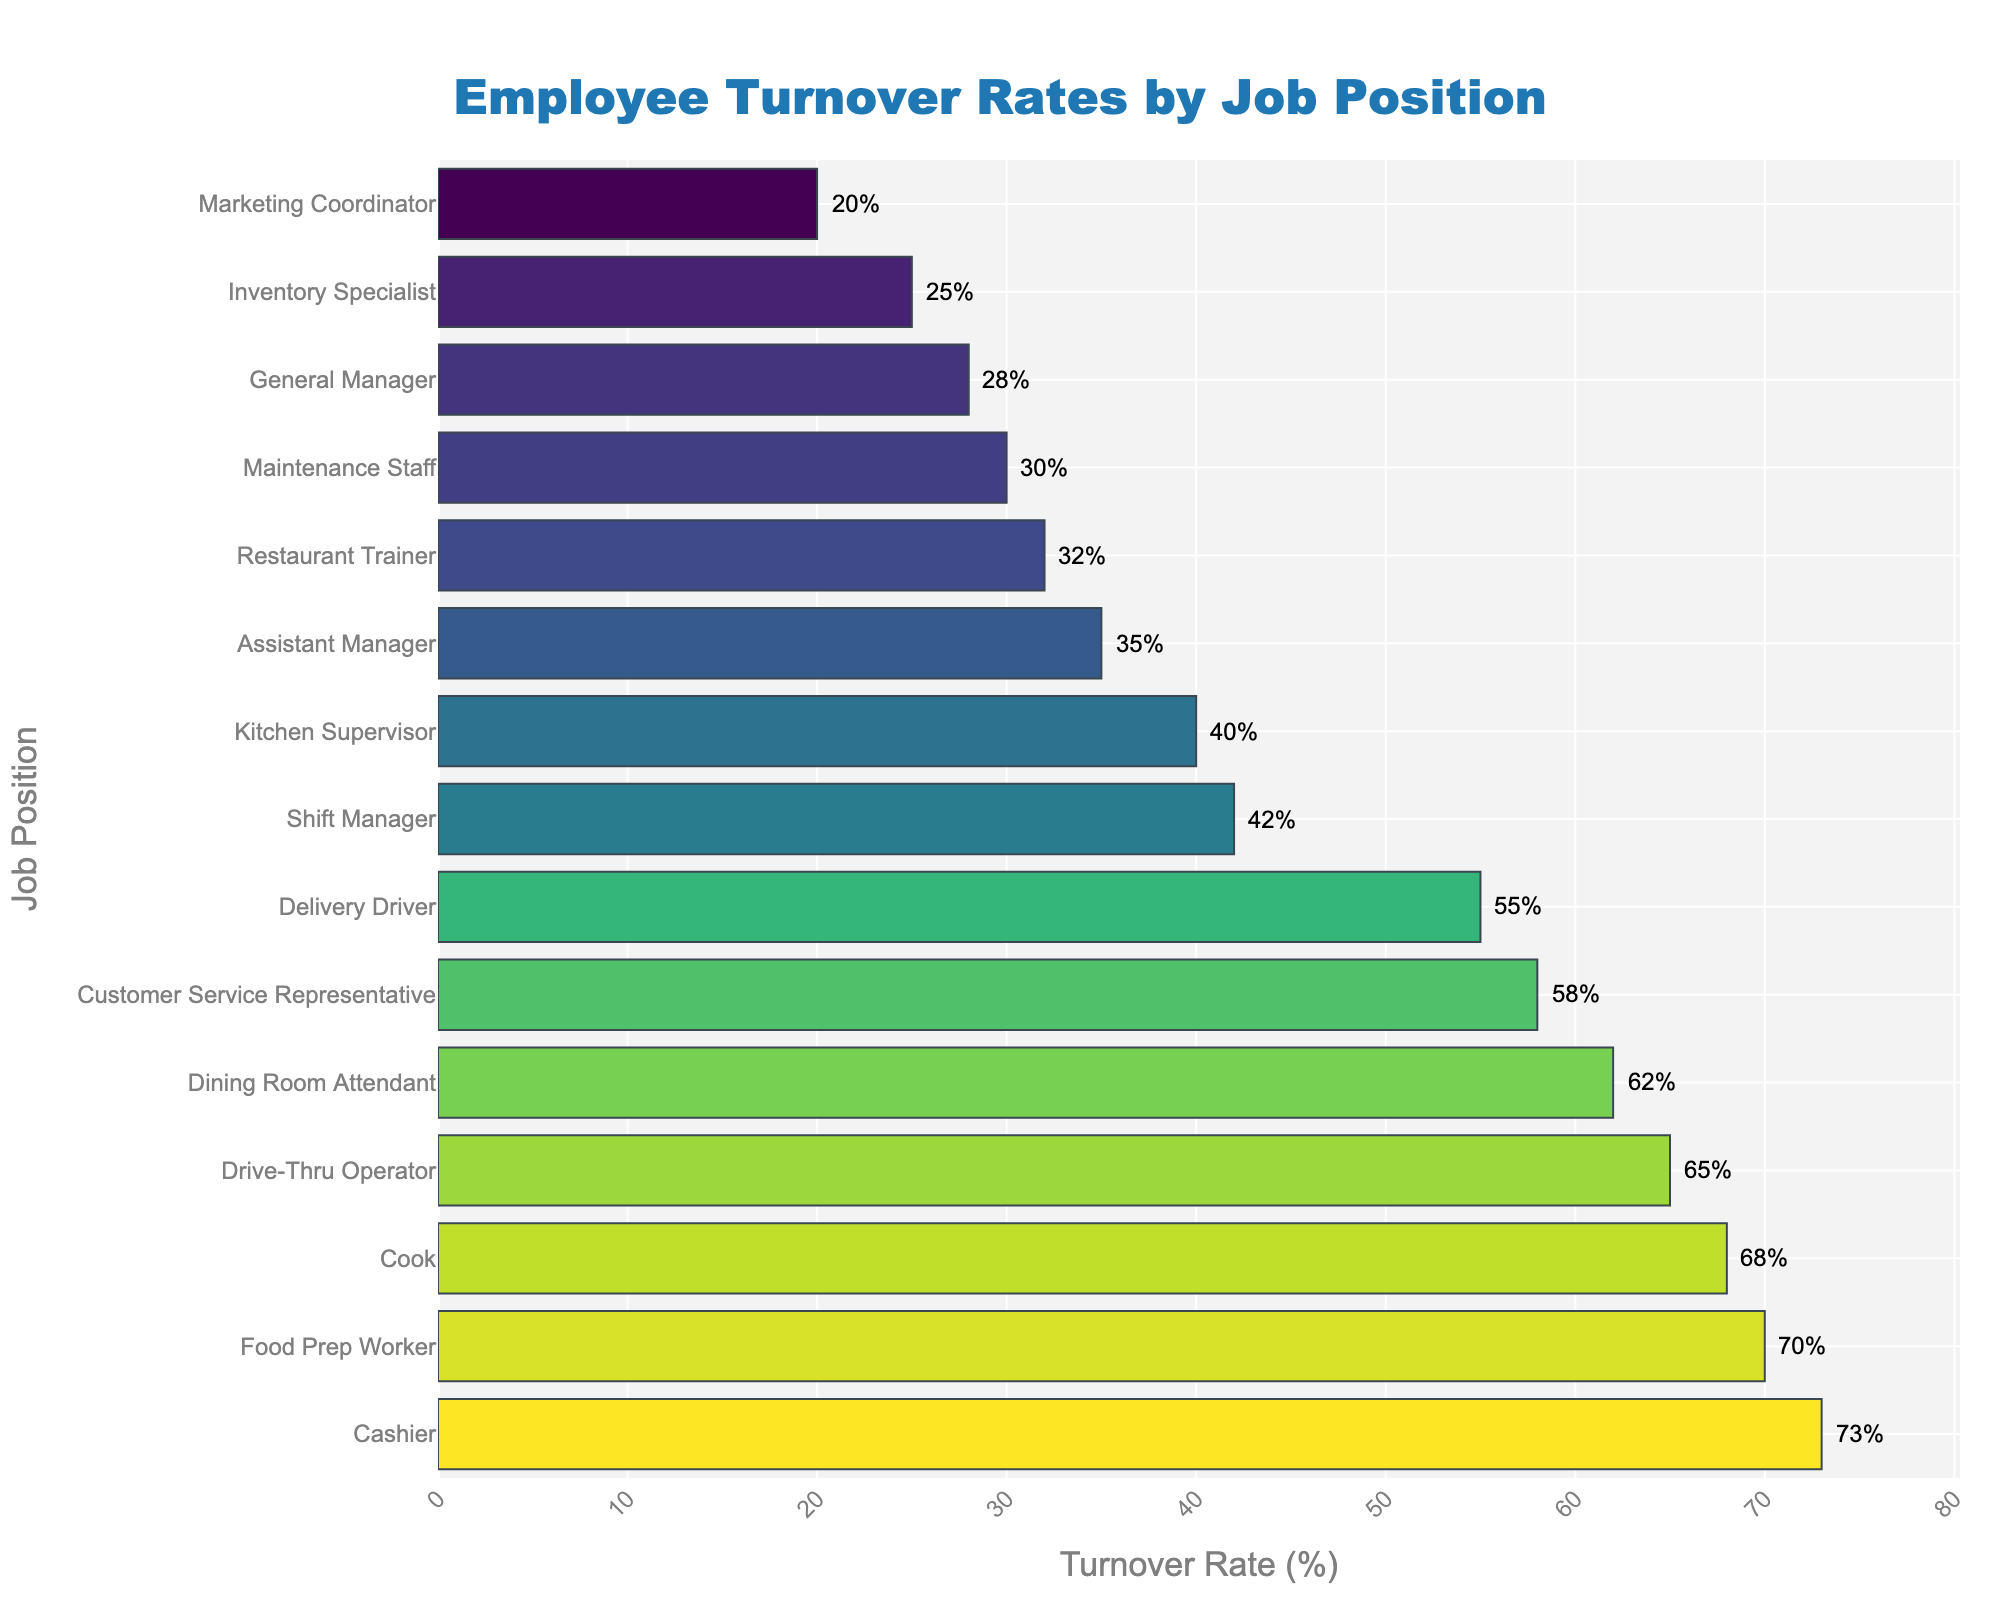What job position has the highest turnover rate? To determine the job position with the highest turnover rate, look for the longest bar in the bar chart, which corresponds to the highest numerical value.
Answer: Cashier Which job position has a lower turnover rate, Assistant Manager or General Manager? Compare the length of the bars corresponding to Assistant Manager and General Manager. The bar for General Manager is shorter, indicating a lower turnover rate.
Answer: General Manager What is the total turnover rate for Cashier, Cook, and Food Prep Worker? Add the turnover rates for Cashier (73%), Cook (68%), and Food Prep Worker (70%). The sum is 73 + 68 + 70 = 211%.
Answer: 211% Is the turnover rate of Shift Manager higher or lower than that of Kitchen Supervisor? Compare the bars for Shift Manager and Kitchen Supervisor. The bar for Shift Manager is slightly higher, indicating a higher turnover rate.
Answer: Higher What is the difference between the turnover rates of Delivery Driver and Drive-Thru Operator? Subtract the turnover rate of Drive-Thru Operator (65%) from that of Delivery Driver (55%). The difference is 65 - 55 = 10%.
Answer: 10% What's the average turnover rate of Maintenance Staff, Dining Room Attendant, and Drive-Thru Operator? Add the turnover rates for Maintenance Staff (30%), Dining Room Attendant (62%), and Drive-Thru Operator (65%), then divide by the number of positions: (30 + 62 + 65) / 3 = 157 / 3 ≈ 52.33%.
Answer: ≈ 52.33% Which job position has a turnover rate closest to 50%? Identify the bar closest to 50% by checking each bar's proximity to the 50% mark. The bar for Delivery Driver at 55% is the closest.
Answer: Delivery Driver How many job positions have a turnover rate lower than 40%? Count the bars that extend less than 40% on the chart: Shift Manager, Assistant Manager, General Manager, Maintenance Staff, Kitchen Supervisor, Restaurant Trainer, Inventory Specialist, and Marketing Coordinator. There are 8 such positions.
Answer: 8 